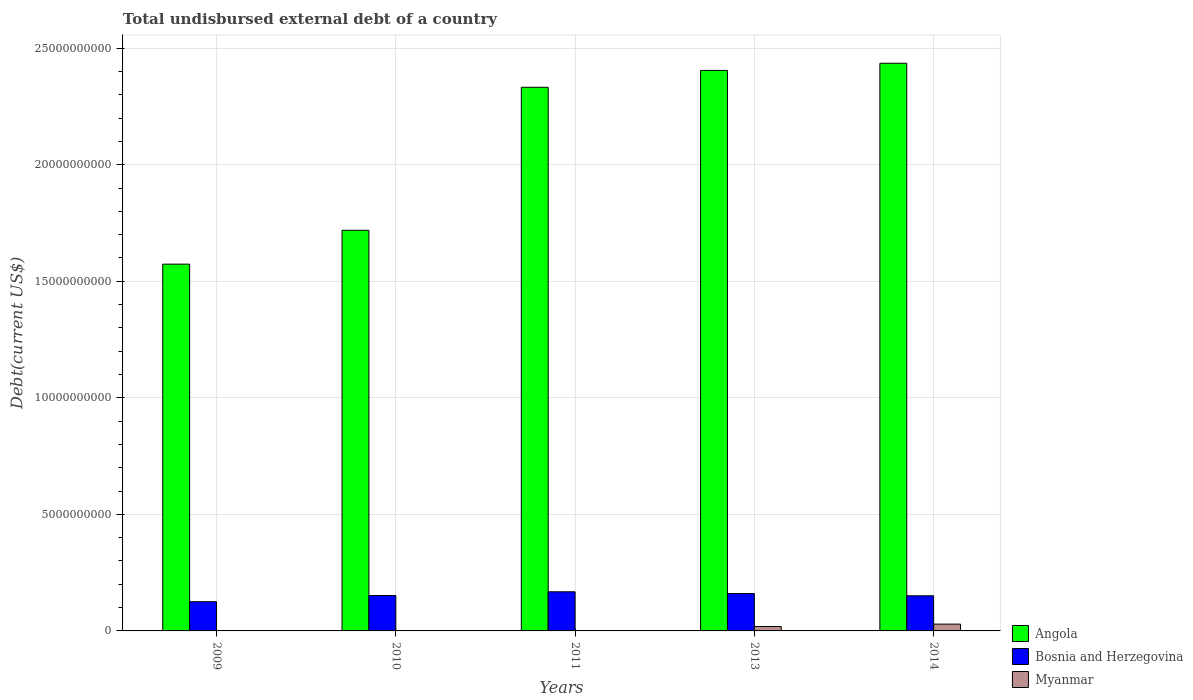How many different coloured bars are there?
Your response must be concise. 3. Are the number of bars on each tick of the X-axis equal?
Give a very brief answer. Yes. How many bars are there on the 4th tick from the left?
Your answer should be compact. 3. What is the label of the 5th group of bars from the left?
Provide a succinct answer. 2014. In how many cases, is the number of bars for a given year not equal to the number of legend labels?
Provide a succinct answer. 0. What is the total undisbursed external debt in Angola in 2014?
Provide a succinct answer. 2.44e+1. Across all years, what is the maximum total undisbursed external debt in Angola?
Make the answer very short. 2.44e+1. Across all years, what is the minimum total undisbursed external debt in Myanmar?
Offer a very short reply. 6.80e+04. In which year was the total undisbursed external debt in Angola minimum?
Your answer should be compact. 2009. What is the total total undisbursed external debt in Angola in the graph?
Provide a short and direct response. 1.05e+11. What is the difference between the total undisbursed external debt in Angola in 2009 and that in 2014?
Provide a succinct answer. -8.62e+09. What is the difference between the total undisbursed external debt in Bosnia and Herzegovina in 2014 and the total undisbursed external debt in Myanmar in 2013?
Your answer should be compact. 1.32e+09. What is the average total undisbursed external debt in Angola per year?
Provide a succinct answer. 2.09e+1. In the year 2010, what is the difference between the total undisbursed external debt in Bosnia and Herzegovina and total undisbursed external debt in Angola?
Your answer should be very brief. -1.57e+1. In how many years, is the total undisbursed external debt in Angola greater than 17000000000 US$?
Ensure brevity in your answer.  4. What is the ratio of the total undisbursed external debt in Myanmar in 2011 to that in 2014?
Make the answer very short. 0. Is the total undisbursed external debt in Myanmar in 2009 less than that in 2014?
Provide a short and direct response. Yes. Is the difference between the total undisbursed external debt in Bosnia and Herzegovina in 2011 and 2013 greater than the difference between the total undisbursed external debt in Angola in 2011 and 2013?
Your response must be concise. Yes. What is the difference between the highest and the second highest total undisbursed external debt in Bosnia and Herzegovina?
Provide a short and direct response. 7.68e+07. What is the difference between the highest and the lowest total undisbursed external debt in Angola?
Your answer should be very brief. 8.62e+09. Is the sum of the total undisbursed external debt in Angola in 2010 and 2011 greater than the maximum total undisbursed external debt in Myanmar across all years?
Ensure brevity in your answer.  Yes. What does the 2nd bar from the left in 2010 represents?
Your answer should be very brief. Bosnia and Herzegovina. What does the 1st bar from the right in 2014 represents?
Offer a terse response. Myanmar. Is it the case that in every year, the sum of the total undisbursed external debt in Bosnia and Herzegovina and total undisbursed external debt in Angola is greater than the total undisbursed external debt in Myanmar?
Give a very brief answer. Yes. Does the graph contain any zero values?
Your answer should be very brief. No. Does the graph contain grids?
Your answer should be very brief. Yes. Where does the legend appear in the graph?
Make the answer very short. Bottom right. How are the legend labels stacked?
Your response must be concise. Vertical. What is the title of the graph?
Keep it short and to the point. Total undisbursed external debt of a country. Does "Channel Islands" appear as one of the legend labels in the graph?
Ensure brevity in your answer.  No. What is the label or title of the X-axis?
Make the answer very short. Years. What is the label or title of the Y-axis?
Your response must be concise. Debt(current US$). What is the Debt(current US$) in Angola in 2009?
Make the answer very short. 1.57e+1. What is the Debt(current US$) in Bosnia and Herzegovina in 2009?
Ensure brevity in your answer.  1.25e+09. What is the Debt(current US$) in Myanmar in 2009?
Offer a very short reply. 6.41e+06. What is the Debt(current US$) of Angola in 2010?
Keep it short and to the point. 1.72e+1. What is the Debt(current US$) in Bosnia and Herzegovina in 2010?
Offer a terse response. 1.52e+09. What is the Debt(current US$) of Myanmar in 2010?
Your answer should be compact. 6.80e+04. What is the Debt(current US$) in Angola in 2011?
Ensure brevity in your answer.  2.33e+1. What is the Debt(current US$) in Bosnia and Herzegovina in 2011?
Provide a short and direct response. 1.68e+09. What is the Debt(current US$) of Myanmar in 2011?
Keep it short and to the point. 6.80e+04. What is the Debt(current US$) in Angola in 2013?
Offer a terse response. 2.40e+1. What is the Debt(current US$) in Bosnia and Herzegovina in 2013?
Offer a terse response. 1.60e+09. What is the Debt(current US$) in Myanmar in 2013?
Keep it short and to the point. 1.89e+08. What is the Debt(current US$) in Angola in 2014?
Your response must be concise. 2.44e+1. What is the Debt(current US$) of Bosnia and Herzegovina in 2014?
Offer a terse response. 1.51e+09. What is the Debt(current US$) of Myanmar in 2014?
Make the answer very short. 2.92e+08. Across all years, what is the maximum Debt(current US$) of Angola?
Keep it short and to the point. 2.44e+1. Across all years, what is the maximum Debt(current US$) of Bosnia and Herzegovina?
Provide a succinct answer. 1.68e+09. Across all years, what is the maximum Debt(current US$) of Myanmar?
Give a very brief answer. 2.92e+08. Across all years, what is the minimum Debt(current US$) of Angola?
Offer a terse response. 1.57e+1. Across all years, what is the minimum Debt(current US$) in Bosnia and Herzegovina?
Offer a very short reply. 1.25e+09. Across all years, what is the minimum Debt(current US$) in Myanmar?
Your answer should be compact. 6.80e+04. What is the total Debt(current US$) of Angola in the graph?
Ensure brevity in your answer.  1.05e+11. What is the total Debt(current US$) of Bosnia and Herzegovina in the graph?
Make the answer very short. 7.56e+09. What is the total Debt(current US$) in Myanmar in the graph?
Your answer should be compact. 4.87e+08. What is the difference between the Debt(current US$) in Angola in 2009 and that in 2010?
Your answer should be very brief. -1.45e+09. What is the difference between the Debt(current US$) of Bosnia and Herzegovina in 2009 and that in 2010?
Provide a succinct answer. -2.64e+08. What is the difference between the Debt(current US$) of Myanmar in 2009 and that in 2010?
Ensure brevity in your answer.  6.34e+06. What is the difference between the Debt(current US$) of Angola in 2009 and that in 2011?
Your answer should be very brief. -7.59e+09. What is the difference between the Debt(current US$) of Bosnia and Herzegovina in 2009 and that in 2011?
Keep it short and to the point. -4.25e+08. What is the difference between the Debt(current US$) of Myanmar in 2009 and that in 2011?
Your response must be concise. 6.34e+06. What is the difference between the Debt(current US$) of Angola in 2009 and that in 2013?
Give a very brief answer. -8.31e+09. What is the difference between the Debt(current US$) in Bosnia and Herzegovina in 2009 and that in 2013?
Ensure brevity in your answer.  -3.48e+08. What is the difference between the Debt(current US$) of Myanmar in 2009 and that in 2013?
Keep it short and to the point. -1.82e+08. What is the difference between the Debt(current US$) in Angola in 2009 and that in 2014?
Offer a very short reply. -8.62e+09. What is the difference between the Debt(current US$) of Bosnia and Herzegovina in 2009 and that in 2014?
Provide a succinct answer. -2.54e+08. What is the difference between the Debt(current US$) of Myanmar in 2009 and that in 2014?
Ensure brevity in your answer.  -2.85e+08. What is the difference between the Debt(current US$) in Angola in 2010 and that in 2011?
Offer a very short reply. -6.13e+09. What is the difference between the Debt(current US$) in Bosnia and Herzegovina in 2010 and that in 2011?
Give a very brief answer. -1.61e+08. What is the difference between the Debt(current US$) in Myanmar in 2010 and that in 2011?
Your answer should be compact. 0. What is the difference between the Debt(current US$) of Angola in 2010 and that in 2013?
Offer a very short reply. -6.86e+09. What is the difference between the Debt(current US$) in Bosnia and Herzegovina in 2010 and that in 2013?
Ensure brevity in your answer.  -8.41e+07. What is the difference between the Debt(current US$) in Myanmar in 2010 and that in 2013?
Keep it short and to the point. -1.89e+08. What is the difference between the Debt(current US$) in Angola in 2010 and that in 2014?
Ensure brevity in your answer.  -7.17e+09. What is the difference between the Debt(current US$) in Bosnia and Herzegovina in 2010 and that in 2014?
Provide a succinct answer. 1.05e+07. What is the difference between the Debt(current US$) of Myanmar in 2010 and that in 2014?
Offer a terse response. -2.92e+08. What is the difference between the Debt(current US$) of Angola in 2011 and that in 2013?
Your response must be concise. -7.22e+08. What is the difference between the Debt(current US$) in Bosnia and Herzegovina in 2011 and that in 2013?
Offer a very short reply. 7.68e+07. What is the difference between the Debt(current US$) in Myanmar in 2011 and that in 2013?
Ensure brevity in your answer.  -1.89e+08. What is the difference between the Debt(current US$) in Angola in 2011 and that in 2014?
Make the answer very short. -1.03e+09. What is the difference between the Debt(current US$) of Bosnia and Herzegovina in 2011 and that in 2014?
Your response must be concise. 1.71e+08. What is the difference between the Debt(current US$) of Myanmar in 2011 and that in 2014?
Provide a succinct answer. -2.92e+08. What is the difference between the Debt(current US$) in Angola in 2013 and that in 2014?
Provide a short and direct response. -3.09e+08. What is the difference between the Debt(current US$) in Bosnia and Herzegovina in 2013 and that in 2014?
Your answer should be compact. 9.46e+07. What is the difference between the Debt(current US$) in Myanmar in 2013 and that in 2014?
Your answer should be compact. -1.03e+08. What is the difference between the Debt(current US$) in Angola in 2009 and the Debt(current US$) in Bosnia and Herzegovina in 2010?
Ensure brevity in your answer.  1.42e+1. What is the difference between the Debt(current US$) in Angola in 2009 and the Debt(current US$) in Myanmar in 2010?
Provide a succinct answer. 1.57e+1. What is the difference between the Debt(current US$) in Bosnia and Herzegovina in 2009 and the Debt(current US$) in Myanmar in 2010?
Your answer should be compact. 1.25e+09. What is the difference between the Debt(current US$) in Angola in 2009 and the Debt(current US$) in Bosnia and Herzegovina in 2011?
Keep it short and to the point. 1.41e+1. What is the difference between the Debt(current US$) of Angola in 2009 and the Debt(current US$) of Myanmar in 2011?
Offer a very short reply. 1.57e+1. What is the difference between the Debt(current US$) of Bosnia and Herzegovina in 2009 and the Debt(current US$) of Myanmar in 2011?
Your answer should be compact. 1.25e+09. What is the difference between the Debt(current US$) in Angola in 2009 and the Debt(current US$) in Bosnia and Herzegovina in 2013?
Ensure brevity in your answer.  1.41e+1. What is the difference between the Debt(current US$) in Angola in 2009 and the Debt(current US$) in Myanmar in 2013?
Make the answer very short. 1.55e+1. What is the difference between the Debt(current US$) of Bosnia and Herzegovina in 2009 and the Debt(current US$) of Myanmar in 2013?
Your answer should be very brief. 1.07e+09. What is the difference between the Debt(current US$) of Angola in 2009 and the Debt(current US$) of Bosnia and Herzegovina in 2014?
Your answer should be compact. 1.42e+1. What is the difference between the Debt(current US$) in Angola in 2009 and the Debt(current US$) in Myanmar in 2014?
Offer a very short reply. 1.54e+1. What is the difference between the Debt(current US$) of Bosnia and Herzegovina in 2009 and the Debt(current US$) of Myanmar in 2014?
Offer a very short reply. 9.62e+08. What is the difference between the Debt(current US$) in Angola in 2010 and the Debt(current US$) in Bosnia and Herzegovina in 2011?
Your answer should be compact. 1.55e+1. What is the difference between the Debt(current US$) of Angola in 2010 and the Debt(current US$) of Myanmar in 2011?
Ensure brevity in your answer.  1.72e+1. What is the difference between the Debt(current US$) in Bosnia and Herzegovina in 2010 and the Debt(current US$) in Myanmar in 2011?
Your response must be concise. 1.52e+09. What is the difference between the Debt(current US$) of Angola in 2010 and the Debt(current US$) of Bosnia and Herzegovina in 2013?
Provide a succinct answer. 1.56e+1. What is the difference between the Debt(current US$) in Angola in 2010 and the Debt(current US$) in Myanmar in 2013?
Your answer should be very brief. 1.70e+1. What is the difference between the Debt(current US$) in Bosnia and Herzegovina in 2010 and the Debt(current US$) in Myanmar in 2013?
Your response must be concise. 1.33e+09. What is the difference between the Debt(current US$) of Angola in 2010 and the Debt(current US$) of Bosnia and Herzegovina in 2014?
Make the answer very short. 1.57e+1. What is the difference between the Debt(current US$) in Angola in 2010 and the Debt(current US$) in Myanmar in 2014?
Ensure brevity in your answer.  1.69e+1. What is the difference between the Debt(current US$) in Bosnia and Herzegovina in 2010 and the Debt(current US$) in Myanmar in 2014?
Make the answer very short. 1.23e+09. What is the difference between the Debt(current US$) in Angola in 2011 and the Debt(current US$) in Bosnia and Herzegovina in 2013?
Make the answer very short. 2.17e+1. What is the difference between the Debt(current US$) of Angola in 2011 and the Debt(current US$) of Myanmar in 2013?
Provide a short and direct response. 2.31e+1. What is the difference between the Debt(current US$) in Bosnia and Herzegovina in 2011 and the Debt(current US$) in Myanmar in 2013?
Your response must be concise. 1.49e+09. What is the difference between the Debt(current US$) of Angola in 2011 and the Debt(current US$) of Bosnia and Herzegovina in 2014?
Make the answer very short. 2.18e+1. What is the difference between the Debt(current US$) of Angola in 2011 and the Debt(current US$) of Myanmar in 2014?
Make the answer very short. 2.30e+1. What is the difference between the Debt(current US$) of Bosnia and Herzegovina in 2011 and the Debt(current US$) of Myanmar in 2014?
Provide a short and direct response. 1.39e+09. What is the difference between the Debt(current US$) in Angola in 2013 and the Debt(current US$) in Bosnia and Herzegovina in 2014?
Give a very brief answer. 2.25e+1. What is the difference between the Debt(current US$) in Angola in 2013 and the Debt(current US$) in Myanmar in 2014?
Offer a very short reply. 2.38e+1. What is the difference between the Debt(current US$) of Bosnia and Herzegovina in 2013 and the Debt(current US$) of Myanmar in 2014?
Offer a very short reply. 1.31e+09. What is the average Debt(current US$) of Angola per year?
Give a very brief answer. 2.09e+1. What is the average Debt(current US$) in Bosnia and Herzegovina per year?
Provide a short and direct response. 1.51e+09. What is the average Debt(current US$) of Myanmar per year?
Provide a short and direct response. 9.74e+07. In the year 2009, what is the difference between the Debt(current US$) of Angola and Debt(current US$) of Bosnia and Herzegovina?
Ensure brevity in your answer.  1.45e+1. In the year 2009, what is the difference between the Debt(current US$) of Angola and Debt(current US$) of Myanmar?
Your response must be concise. 1.57e+1. In the year 2009, what is the difference between the Debt(current US$) of Bosnia and Herzegovina and Debt(current US$) of Myanmar?
Keep it short and to the point. 1.25e+09. In the year 2010, what is the difference between the Debt(current US$) of Angola and Debt(current US$) of Bosnia and Herzegovina?
Offer a very short reply. 1.57e+1. In the year 2010, what is the difference between the Debt(current US$) of Angola and Debt(current US$) of Myanmar?
Make the answer very short. 1.72e+1. In the year 2010, what is the difference between the Debt(current US$) in Bosnia and Herzegovina and Debt(current US$) in Myanmar?
Your answer should be compact. 1.52e+09. In the year 2011, what is the difference between the Debt(current US$) of Angola and Debt(current US$) of Bosnia and Herzegovina?
Offer a terse response. 2.16e+1. In the year 2011, what is the difference between the Debt(current US$) in Angola and Debt(current US$) in Myanmar?
Your response must be concise. 2.33e+1. In the year 2011, what is the difference between the Debt(current US$) in Bosnia and Herzegovina and Debt(current US$) in Myanmar?
Keep it short and to the point. 1.68e+09. In the year 2013, what is the difference between the Debt(current US$) in Angola and Debt(current US$) in Bosnia and Herzegovina?
Your response must be concise. 2.24e+1. In the year 2013, what is the difference between the Debt(current US$) in Angola and Debt(current US$) in Myanmar?
Offer a terse response. 2.39e+1. In the year 2013, what is the difference between the Debt(current US$) of Bosnia and Herzegovina and Debt(current US$) of Myanmar?
Make the answer very short. 1.41e+09. In the year 2014, what is the difference between the Debt(current US$) of Angola and Debt(current US$) of Bosnia and Herzegovina?
Make the answer very short. 2.28e+1. In the year 2014, what is the difference between the Debt(current US$) of Angola and Debt(current US$) of Myanmar?
Offer a very short reply. 2.41e+1. In the year 2014, what is the difference between the Debt(current US$) of Bosnia and Herzegovina and Debt(current US$) of Myanmar?
Your answer should be compact. 1.22e+09. What is the ratio of the Debt(current US$) of Angola in 2009 to that in 2010?
Offer a terse response. 0.92. What is the ratio of the Debt(current US$) of Bosnia and Herzegovina in 2009 to that in 2010?
Your answer should be very brief. 0.83. What is the ratio of the Debt(current US$) of Myanmar in 2009 to that in 2010?
Offer a very short reply. 94.31. What is the ratio of the Debt(current US$) in Angola in 2009 to that in 2011?
Make the answer very short. 0.67. What is the ratio of the Debt(current US$) in Bosnia and Herzegovina in 2009 to that in 2011?
Give a very brief answer. 0.75. What is the ratio of the Debt(current US$) in Myanmar in 2009 to that in 2011?
Provide a short and direct response. 94.31. What is the ratio of the Debt(current US$) in Angola in 2009 to that in 2013?
Make the answer very short. 0.65. What is the ratio of the Debt(current US$) in Bosnia and Herzegovina in 2009 to that in 2013?
Offer a terse response. 0.78. What is the ratio of the Debt(current US$) of Myanmar in 2009 to that in 2013?
Offer a very short reply. 0.03. What is the ratio of the Debt(current US$) in Angola in 2009 to that in 2014?
Offer a terse response. 0.65. What is the ratio of the Debt(current US$) in Bosnia and Herzegovina in 2009 to that in 2014?
Offer a very short reply. 0.83. What is the ratio of the Debt(current US$) of Myanmar in 2009 to that in 2014?
Provide a succinct answer. 0.02. What is the ratio of the Debt(current US$) of Angola in 2010 to that in 2011?
Offer a terse response. 0.74. What is the ratio of the Debt(current US$) of Bosnia and Herzegovina in 2010 to that in 2011?
Provide a succinct answer. 0.9. What is the ratio of the Debt(current US$) in Angola in 2010 to that in 2013?
Keep it short and to the point. 0.71. What is the ratio of the Debt(current US$) of Bosnia and Herzegovina in 2010 to that in 2013?
Your response must be concise. 0.95. What is the ratio of the Debt(current US$) of Myanmar in 2010 to that in 2013?
Ensure brevity in your answer.  0. What is the ratio of the Debt(current US$) in Angola in 2010 to that in 2014?
Your answer should be compact. 0.71. What is the ratio of the Debt(current US$) in Bosnia and Herzegovina in 2011 to that in 2013?
Your answer should be compact. 1.05. What is the ratio of the Debt(current US$) in Myanmar in 2011 to that in 2013?
Ensure brevity in your answer.  0. What is the ratio of the Debt(current US$) in Angola in 2011 to that in 2014?
Your response must be concise. 0.96. What is the ratio of the Debt(current US$) of Bosnia and Herzegovina in 2011 to that in 2014?
Offer a terse response. 1.11. What is the ratio of the Debt(current US$) of Angola in 2013 to that in 2014?
Give a very brief answer. 0.99. What is the ratio of the Debt(current US$) of Bosnia and Herzegovina in 2013 to that in 2014?
Make the answer very short. 1.06. What is the ratio of the Debt(current US$) of Myanmar in 2013 to that in 2014?
Make the answer very short. 0.65. What is the difference between the highest and the second highest Debt(current US$) of Angola?
Make the answer very short. 3.09e+08. What is the difference between the highest and the second highest Debt(current US$) in Bosnia and Herzegovina?
Your answer should be very brief. 7.68e+07. What is the difference between the highest and the second highest Debt(current US$) of Myanmar?
Your response must be concise. 1.03e+08. What is the difference between the highest and the lowest Debt(current US$) in Angola?
Offer a terse response. 8.62e+09. What is the difference between the highest and the lowest Debt(current US$) of Bosnia and Herzegovina?
Ensure brevity in your answer.  4.25e+08. What is the difference between the highest and the lowest Debt(current US$) in Myanmar?
Keep it short and to the point. 2.92e+08. 